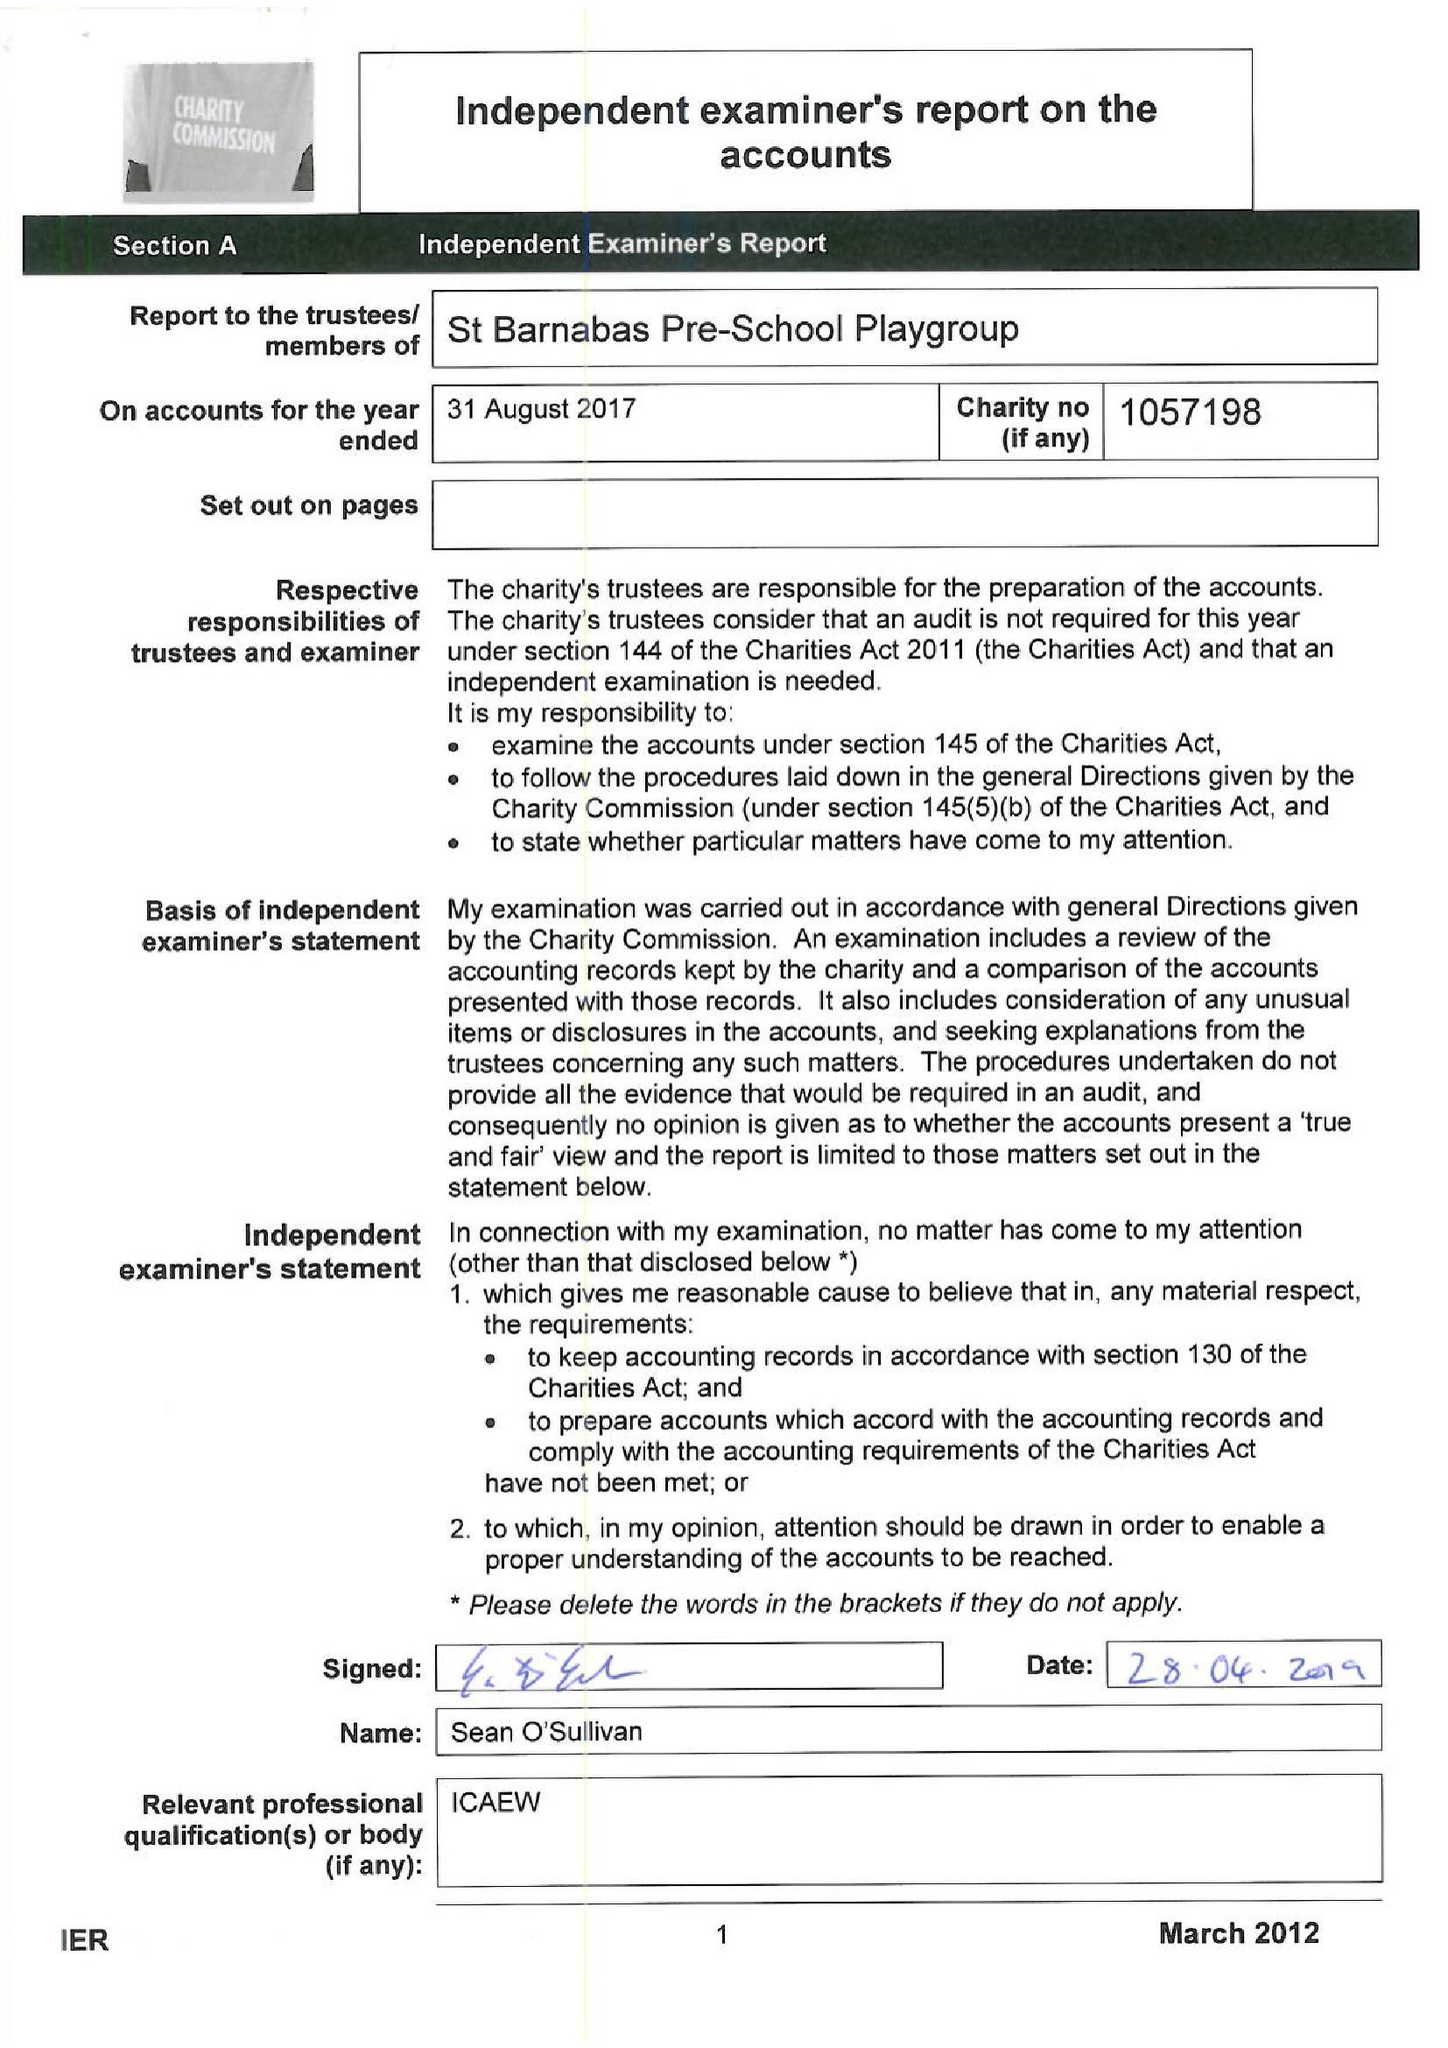What is the value for the address__street_line?
Answer the question using a single word or phrase. PITSHANGER LANE 